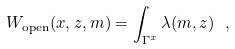Convert formula to latex. <formula><loc_0><loc_0><loc_500><loc_500>W _ { \text {open} } ( x , z , m ) = \int _ { \Gamma ^ { x } } \lambda ( m , z ) \ ,</formula> 